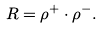Convert formula to latex. <formula><loc_0><loc_0><loc_500><loc_500>R = \rho ^ { + } \cdot \rho ^ { - } .</formula> 